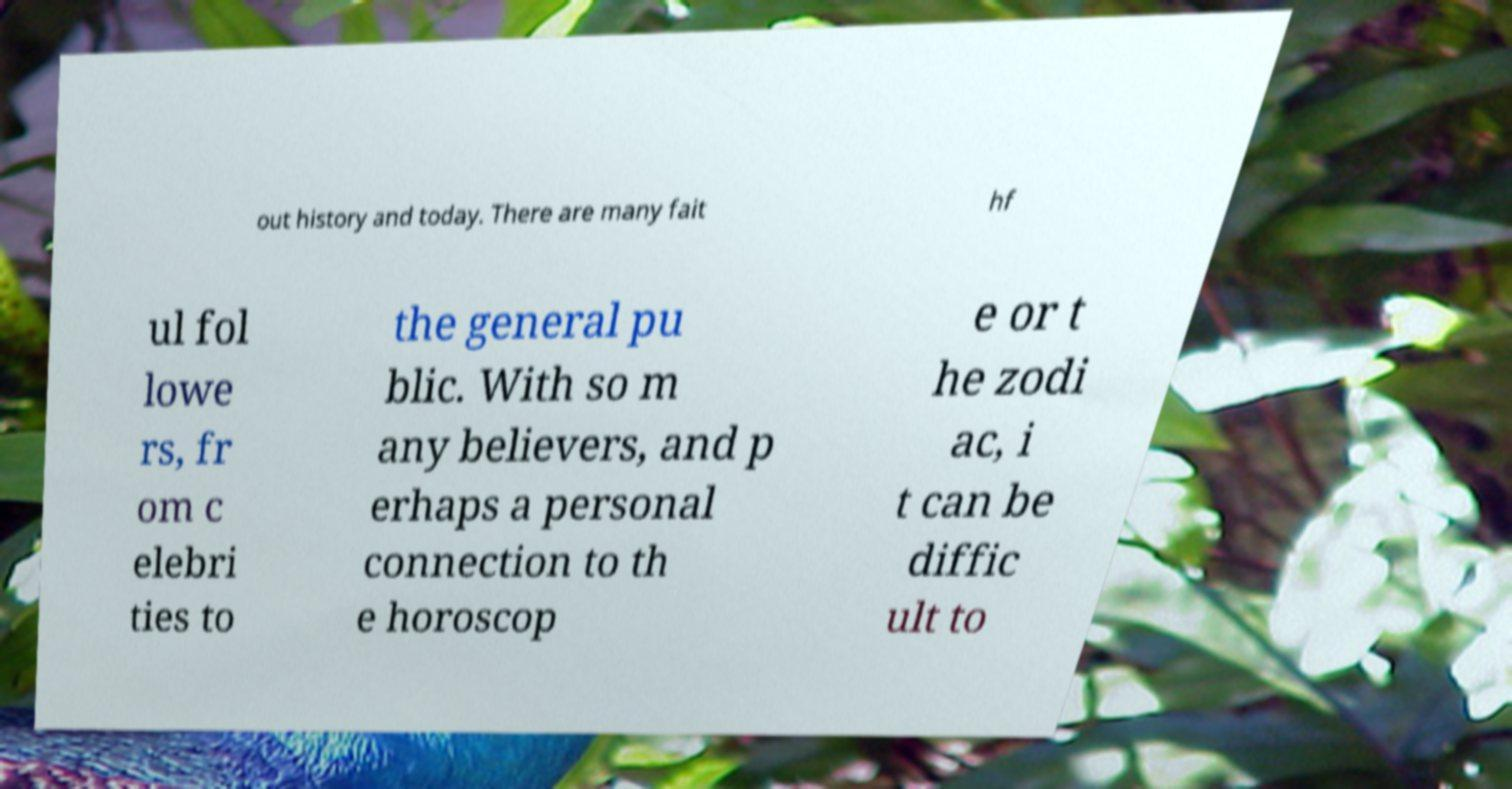What messages or text are displayed in this image? I need them in a readable, typed format. out history and today. There are many fait hf ul fol lowe rs, fr om c elebri ties to the general pu blic. With so m any believers, and p erhaps a personal connection to th e horoscop e or t he zodi ac, i t can be diffic ult to 